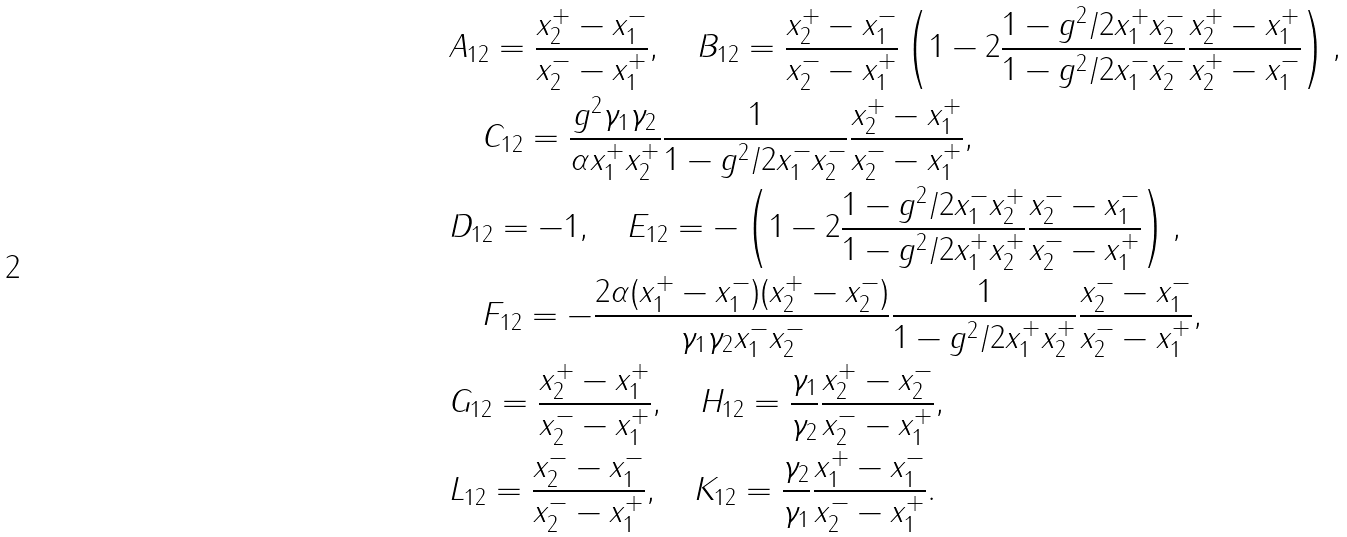Convert formula to latex. <formula><loc_0><loc_0><loc_500><loc_500>& A _ { 1 2 } = \frac { x _ { 2 } ^ { + } - x _ { 1 } ^ { - } } { x _ { 2 } ^ { - } - x _ { 1 } ^ { + } } , \quad B _ { 1 2 } = \frac { x _ { 2 } ^ { + } - x _ { 1 } ^ { - } } { x _ { 2 } ^ { - } - x _ { 1 } ^ { + } } \left ( 1 - 2 \frac { 1 - g ^ { 2 } / 2 x _ { 1 } ^ { + } x _ { 2 } ^ { - } } { 1 - g ^ { 2 } / 2 x _ { 1 } ^ { - } x _ { 2 } ^ { - } } \frac { x _ { 2 } ^ { + } - x _ { 1 } ^ { + } } { x _ { 2 } ^ { + } - x _ { 1 } ^ { - } } \right ) , \\ & \quad C _ { 1 2 } = \frac { g ^ { 2 } \gamma _ { 1 } \gamma _ { 2 } } { \alpha x _ { 1 } ^ { + } x _ { 2 } ^ { + } } \frac { 1 } { 1 - g ^ { 2 } / 2 x _ { 1 } ^ { - } x _ { 2 } ^ { - } } \frac { x _ { 2 } ^ { + } - x _ { 1 } ^ { + } } { x _ { 2 } ^ { - } - x _ { 1 } ^ { + } } , \\ & D _ { 1 2 } = - 1 , \quad E _ { 1 2 } = - \left ( 1 - 2 \frac { 1 - g ^ { 2 } / 2 x _ { 1 } ^ { - } x _ { 2 } ^ { + } } { 1 - g ^ { 2 } / 2 x _ { 1 } ^ { + } x _ { 2 } ^ { + } } \frac { x _ { 2 } ^ { - } - x _ { 1 } ^ { - } } { x _ { 2 } ^ { - } - x _ { 1 } ^ { + } } \right ) , \\ & \quad F _ { 1 2 } = - \frac { 2 \alpha ( x _ { 1 } ^ { + } - x _ { 1 } ^ { - } ) ( x _ { 2 } ^ { + } - x _ { 2 } ^ { - } ) } { \gamma _ { 1 } \gamma _ { 2 } x _ { 1 } ^ { - } x _ { 2 } ^ { - } } \frac { 1 } { 1 - g ^ { 2 } / 2 x _ { 1 } ^ { + } x _ { 2 } ^ { + } } \frac { x _ { 2 } ^ { - } - x _ { 1 } ^ { - } } { x _ { 2 } ^ { - } - x _ { 1 } ^ { + } } , \\ & G _ { 1 2 } = \frac { x _ { 2 } ^ { + } - x _ { 1 } ^ { + } } { x _ { 2 } ^ { - } - x _ { 1 } ^ { + } } , \quad H _ { 1 2 } = \frac { \gamma _ { 1 } } { \gamma _ { 2 } } \frac { x _ { 2 } ^ { + } - x _ { 2 } ^ { - } } { x _ { 2 } ^ { - } - x _ { 1 } ^ { + } } , \\ & L _ { 1 2 } = \frac { x _ { 2 } ^ { - } - x _ { 1 } ^ { - } } { x _ { 2 } ^ { - } - x _ { 1 } ^ { + } } , \quad K _ { 1 2 } = \frac { \gamma _ { 2 } } { \gamma _ { 1 } } \frac { x _ { 1 } ^ { + } - x _ { 1 } ^ { - } } { x _ { 2 } ^ { - } - x _ { 1 } ^ { + } } .</formula> 